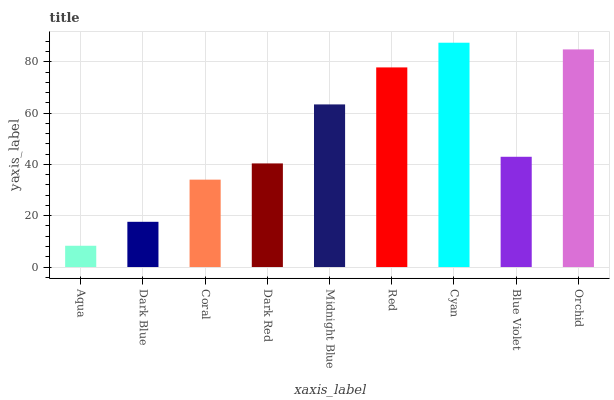Is Aqua the minimum?
Answer yes or no. Yes. Is Cyan the maximum?
Answer yes or no. Yes. Is Dark Blue the minimum?
Answer yes or no. No. Is Dark Blue the maximum?
Answer yes or no. No. Is Dark Blue greater than Aqua?
Answer yes or no. Yes. Is Aqua less than Dark Blue?
Answer yes or no. Yes. Is Aqua greater than Dark Blue?
Answer yes or no. No. Is Dark Blue less than Aqua?
Answer yes or no. No. Is Blue Violet the high median?
Answer yes or no. Yes. Is Blue Violet the low median?
Answer yes or no. Yes. Is Dark Red the high median?
Answer yes or no. No. Is Cyan the low median?
Answer yes or no. No. 